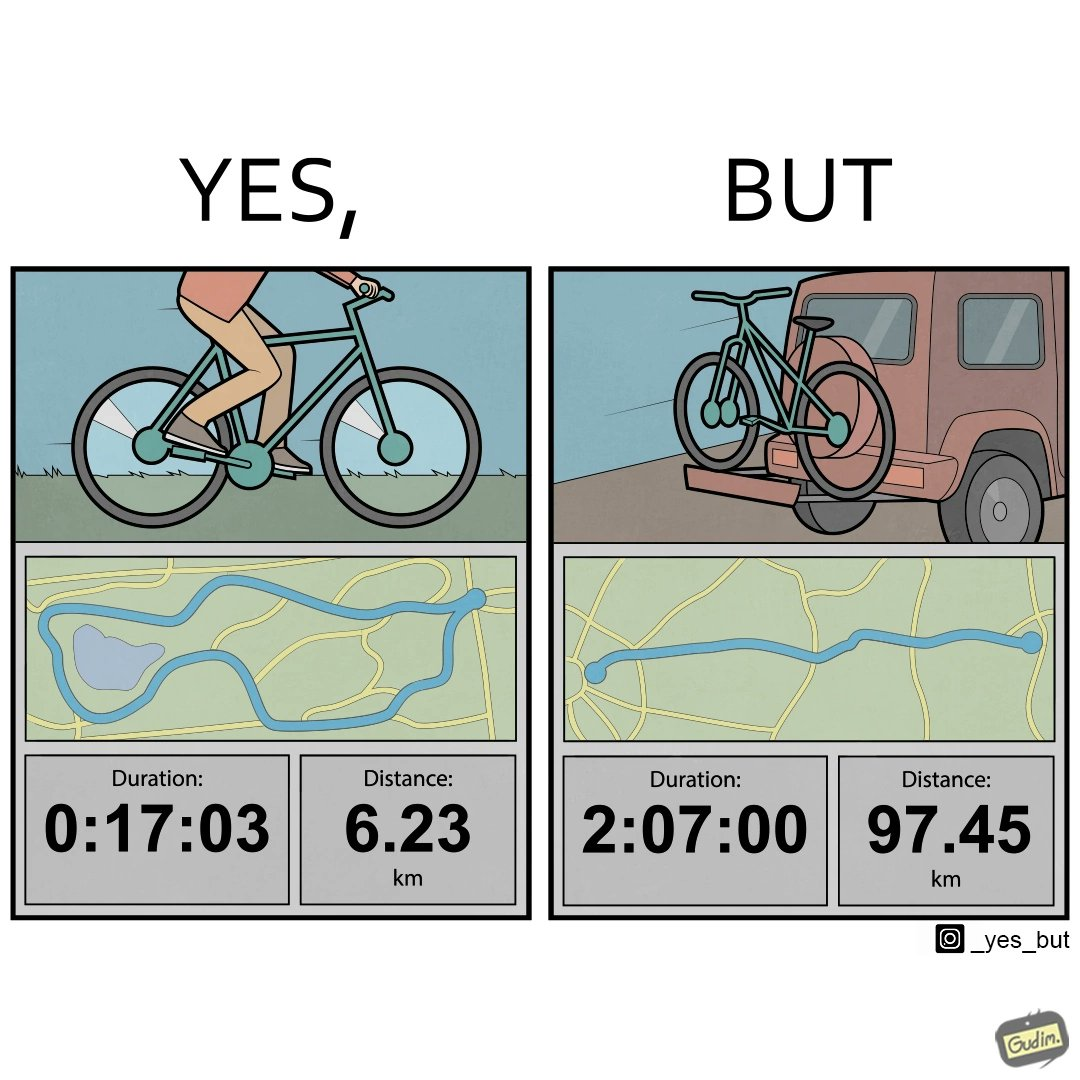Describe what you see in the left and right parts of this image. In the left part of the image: someone riding a bicycle with a map below, highlighting duration and distance covered, maybe by the bicycle In the right part of the image: a car carrying a cycle by keeping it at the backside with a map below, highlighting duration and distance covered, maybe by the car 